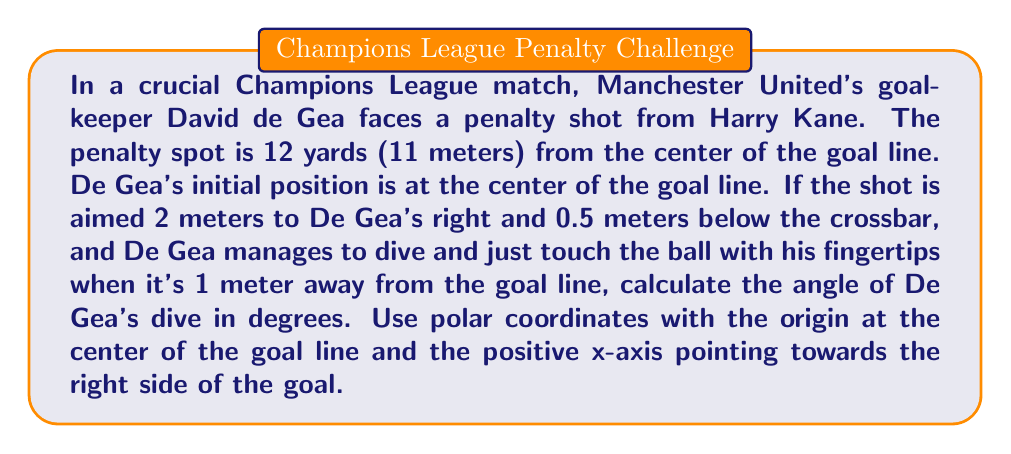Help me with this question. Let's approach this step-by-step using polar coordinates:

1) First, we need to determine the coordinates of the ball when De Gea touches it. 
   - x-coordinate: 2 meters (to De Gea's right)
   - y-coordinate: 10 meters (1 meter in front of the goal line)

2) In polar coordinates, we have:
   $$r = \sqrt{x^2 + y^2}$$
   $$\theta = \arctan(\frac{y}{x})$$

3) Calculate r:
   $$r = \sqrt{2^2 + 10^2} = \sqrt{4 + 100} = \sqrt{104} \approx 10.20 \text{ meters}$$

4) Calculate θ:
   $$\theta = \arctan(\frac{10}{2}) = \arctan(5)$$

5) Convert θ from radians to degrees:
   $$\theta = \arctan(5) * \frac{180}{\pi} \approx 78.69°$$

6) This angle is measured from the positive x-axis. To get De Gea's dive angle from his initial position (which is along the y-axis), we need to subtract this from 90°:

   $$\text{Dive Angle} = 90° - 78.69° = 11.31°$$

Therefore, De Gea's dive angle is approximately 11.31° to his right.
Answer: 11.31° 